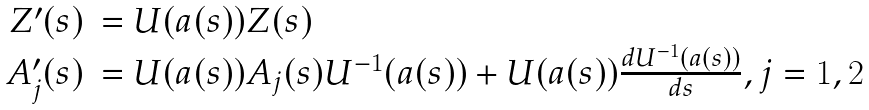<formula> <loc_0><loc_0><loc_500><loc_500>\begin{array} { r l } Z ^ { \prime } ( s ) & = U ( a ( s ) ) Z ( s ) \\ A _ { j } ^ { \prime } ( s ) & = U ( a ( s ) ) A _ { j } ( s ) U ^ { - 1 } ( a ( s ) ) + U ( a ( s ) ) \frac { d U ^ { - 1 } ( a ( s ) ) } { d s } , j = 1 , 2 \end{array}</formula> 